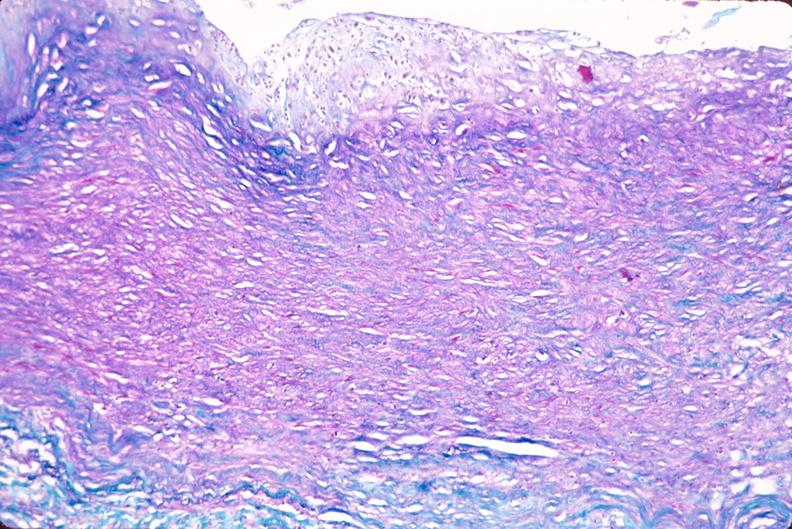s artery present?
Answer the question using a single word or phrase. No 